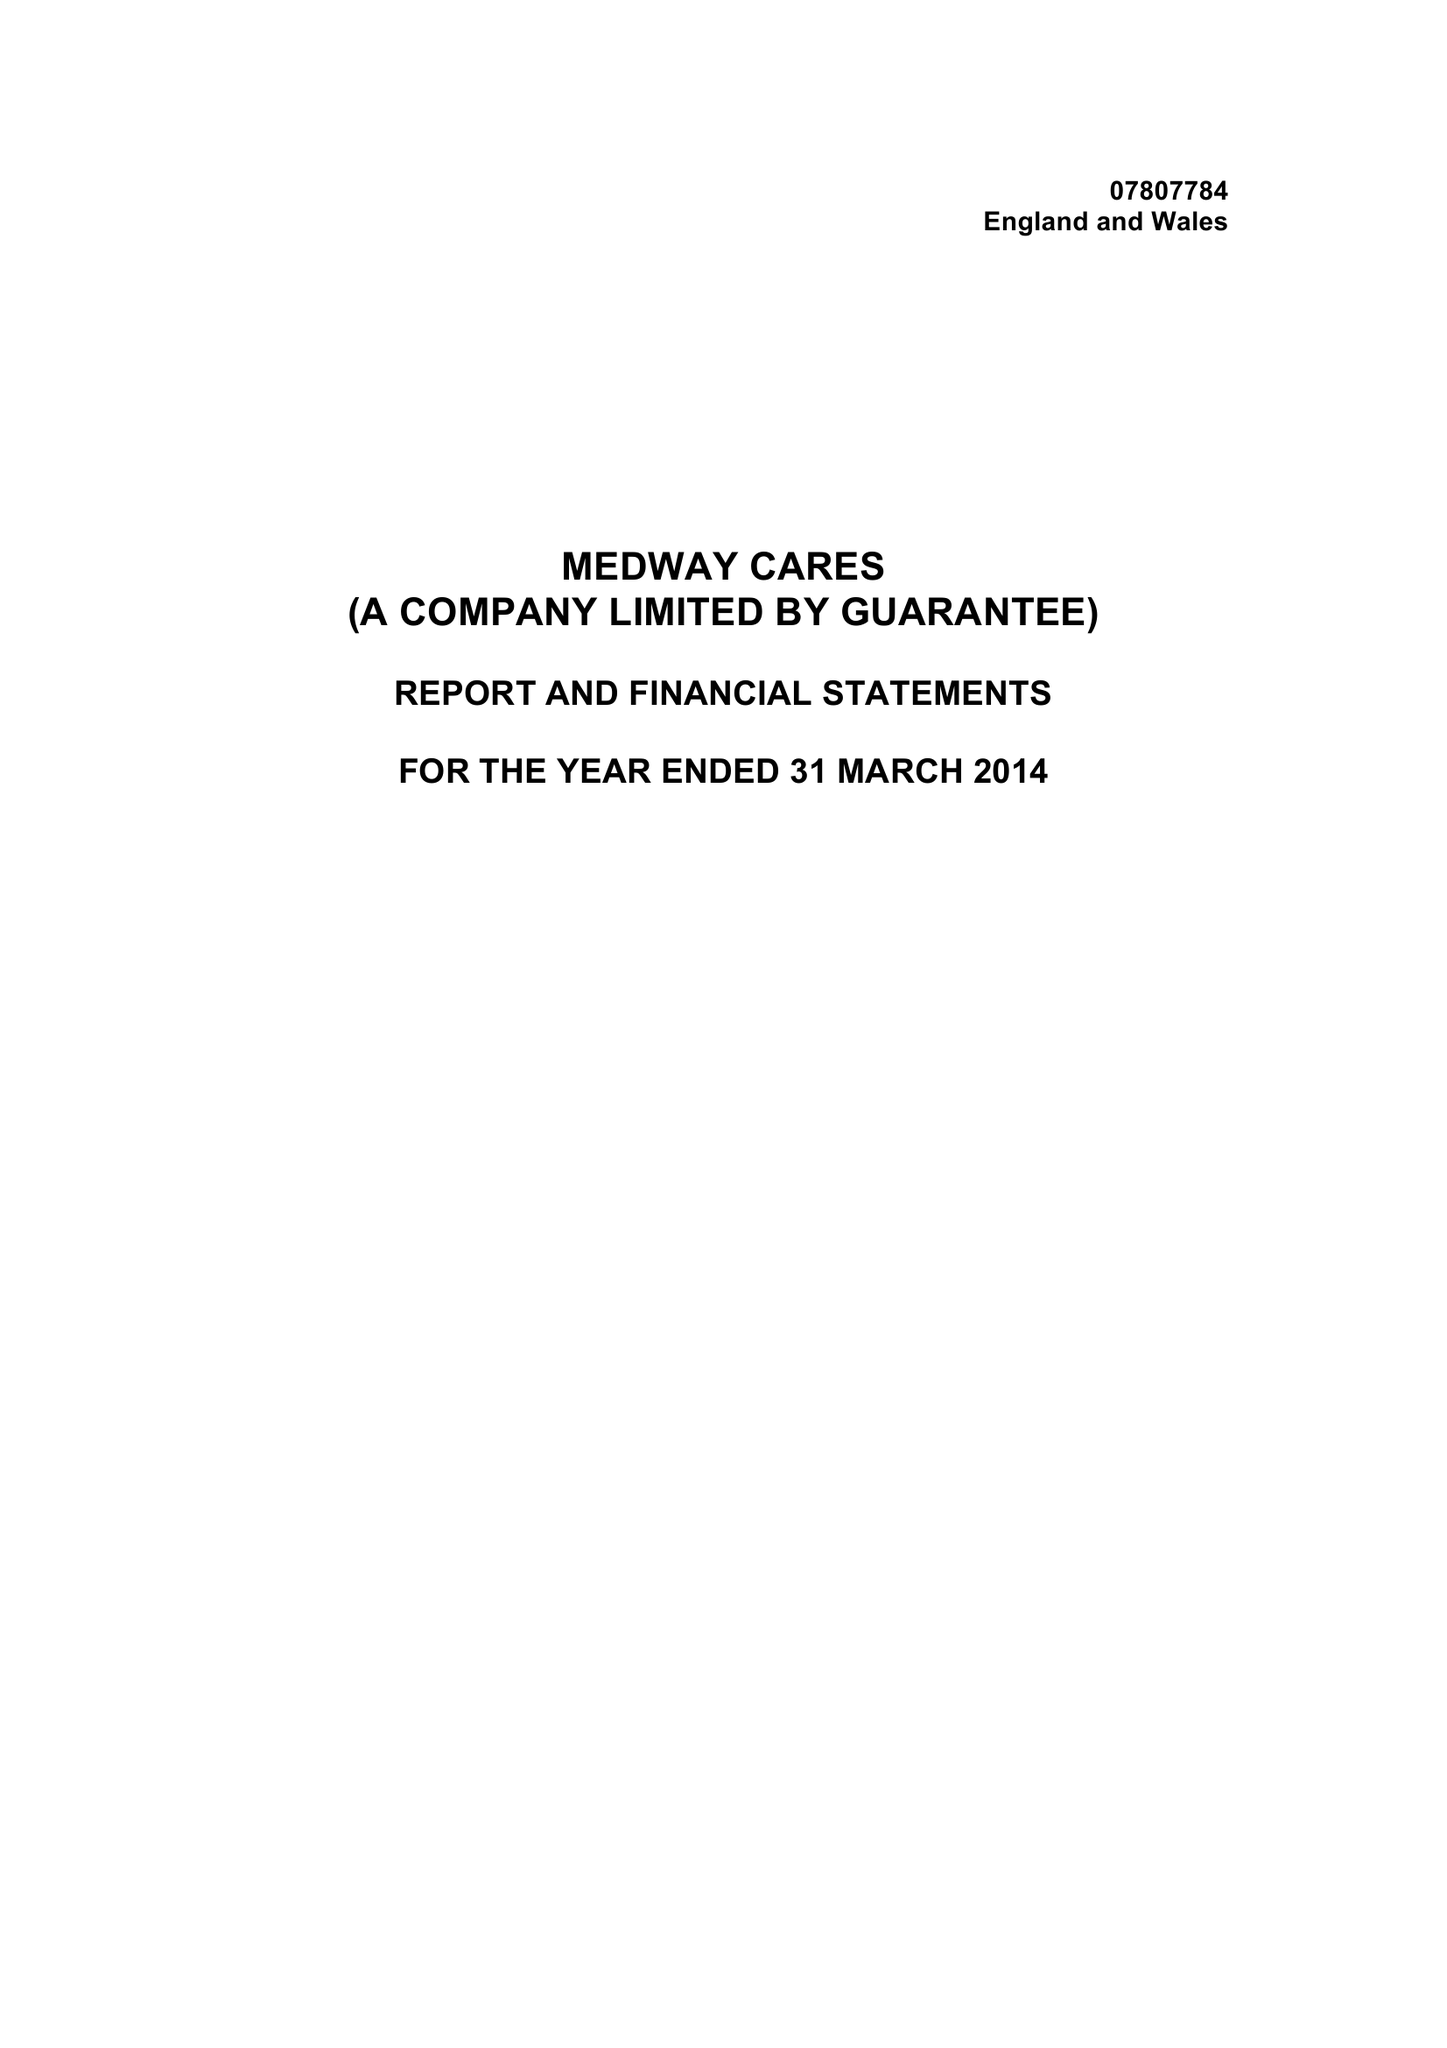What is the value for the address__postcode?
Answer the question using a single word or phrase. ME8 0PZ 